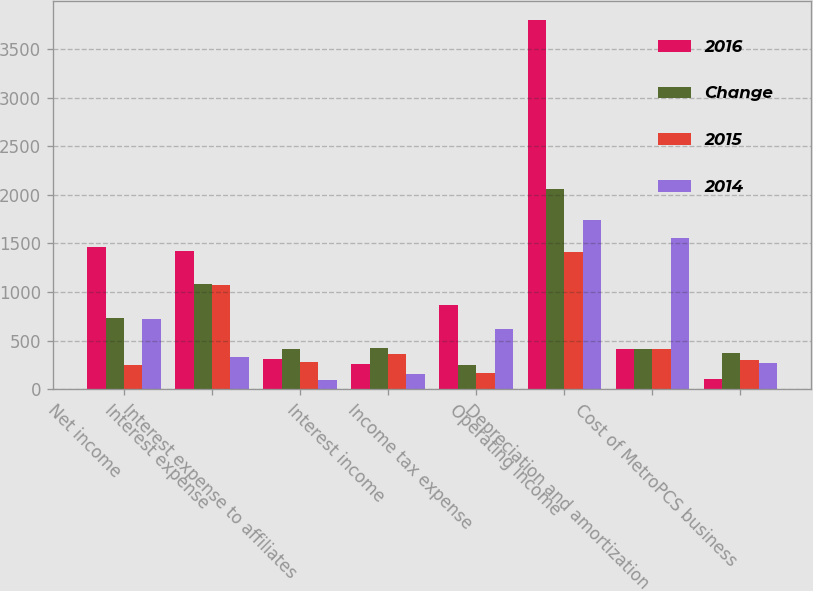<chart> <loc_0><loc_0><loc_500><loc_500><stacked_bar_chart><ecel><fcel>Net income<fcel>Interest expense<fcel>Interest expense to affiliates<fcel>Interest income<fcel>Income tax expense<fcel>Operating income<fcel>Depreciation and amortization<fcel>Cost of MetroPCS business<nl><fcel>2016<fcel>1460<fcel>1418<fcel>312<fcel>261<fcel>867<fcel>3802<fcel>411<fcel>104<nl><fcel>Change<fcel>733<fcel>1085<fcel>411<fcel>420<fcel>245<fcel>2065<fcel>411<fcel>376<nl><fcel>2015<fcel>247<fcel>1073<fcel>278<fcel>359<fcel>166<fcel>1416<fcel>411<fcel>299<nl><fcel>2014<fcel>727<fcel>333<fcel>99<fcel>159<fcel>622<fcel>1737<fcel>1555<fcel>272<nl></chart> 